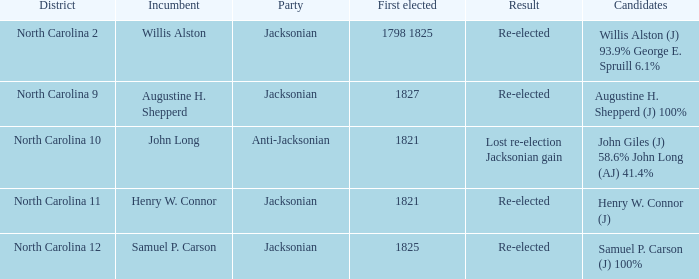Name the total number of party for willis alston (j) 93.9% george e. spruill 6.1% 1.0. 